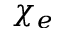<formula> <loc_0><loc_0><loc_500><loc_500>\chi _ { e }</formula> 